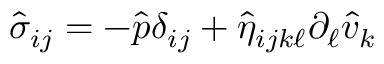Convert formula to latex. <formula><loc_0><loc_0><loc_500><loc_500>\hat { \sigma } _ { i j } = - \hat { p } \delta _ { i j } + \hat { \eta } _ { i j k \ell } \partial _ { \ell } \hat { v } _ { k }</formula> 